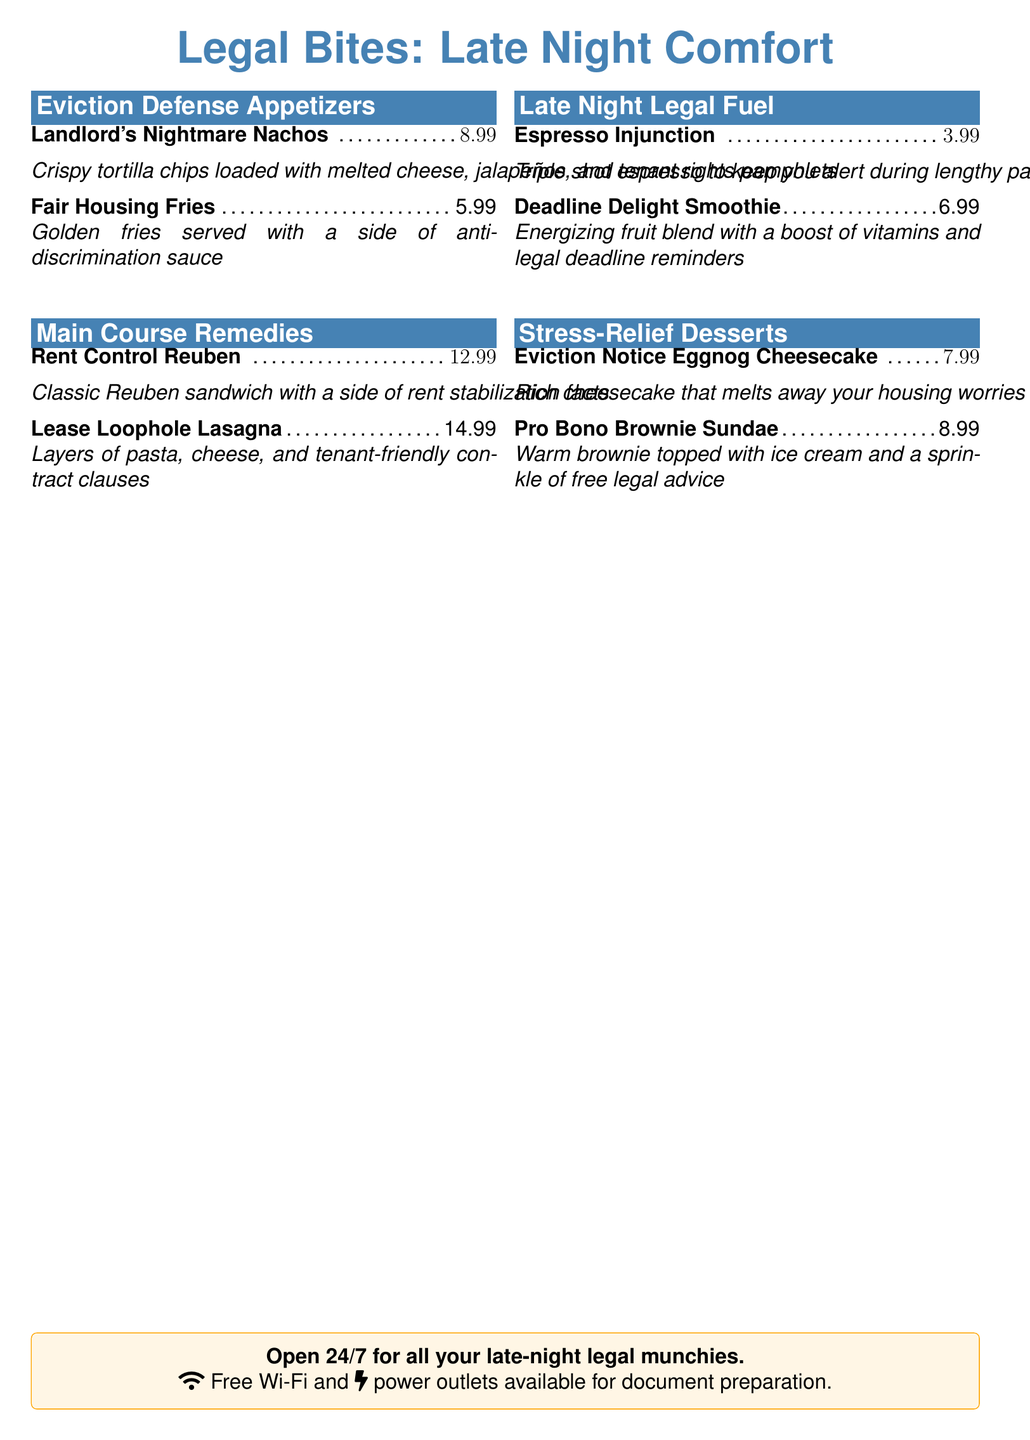What is the name of the late-night menu? The document features a late-night menu titled "Legal Bites: Late Night Comfort."
Answer: Legal Bites: Late Night Comfort What are the two sections in the dessert menu? The dessert menu has two sections titled "Stress-Relief Desserts."
Answer: Stress-Relief Desserts How much do the Fair Housing Fries cost? The price of the Fair Housing Fries is explicitly stated in the menu.
Answer: $5.99 What is included with the Rent Control Reuben? The item description mentions a side that accompanies the main dish.
Answer: a side of rent stabilization facts How much does the Deadline Delight Smoothie cost? The menu lists the price of the Deadline Delight Smoothie clearly.
Answer: $6.99 What additional service is offered in the restaurant? The tcolorbox at the bottom emphasizes an additional service for patrons.
Answer: Free Wi-Fi How many appetizers are listed in the menu? The number of appetizing options in the "Eviction Defense Appetizers" section indicates how many there are.
Answer: 2 What is a unique feature of the Pro Bono Brownie Sundae? The description of this dessert includes a notable aspect related to legal assistance.
Answer: free legal advice What type of drink is the Espresso Injunction? The drink is categorized to indicate its nature and effects.
Answer: Triple shot espresso 